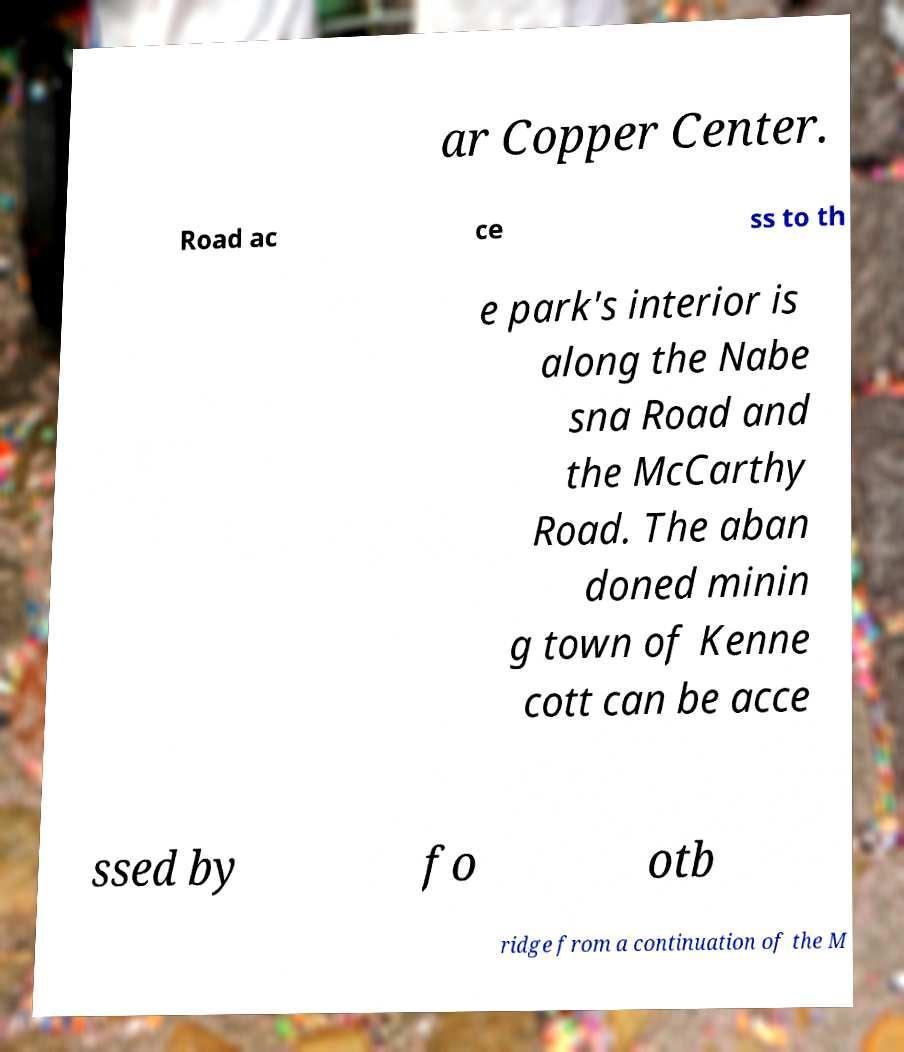Can you read and provide the text displayed in the image?This photo seems to have some interesting text. Can you extract and type it out for me? ar Copper Center. Road ac ce ss to th e park's interior is along the Nabe sna Road and the McCarthy Road. The aban doned minin g town of Kenne cott can be acce ssed by fo otb ridge from a continuation of the M 